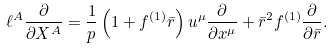<formula> <loc_0><loc_0><loc_500><loc_500>\ell ^ { A } \frac { \partial } { \partial X ^ { A } } = \frac { 1 } { p } \left ( 1 + f ^ { ( 1 ) } \bar { r } \right ) u ^ { \mu } \frac { \partial } { \partial x ^ { \mu } } + \bar { r } ^ { 2 } f ^ { ( 1 ) } \frac { \partial } { \partial \bar { r } } .</formula> 